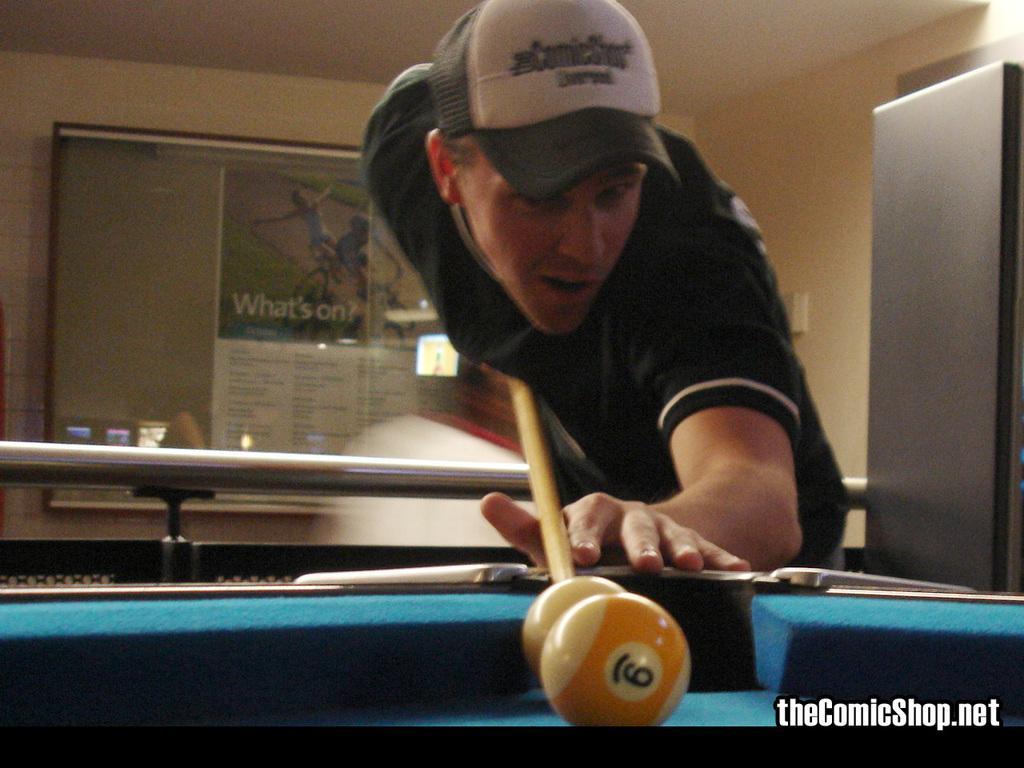How would you summarize this image in a sentence or two? In this image there is one person who is holding a stick and playing table tennis, in the background there is a wall and some board. On the top there is ceiling. 